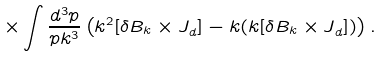Convert formula to latex. <formula><loc_0><loc_0><loc_500><loc_500>\times \int \frac { d ^ { 3 } p } { p k ^ { 3 } } \left ( k ^ { 2 } { [ \delta B _ { k } \times J } _ { d } ] - { k ( k [ \delta B _ { k } \times J } _ { d } ] ) \right ) .</formula> 